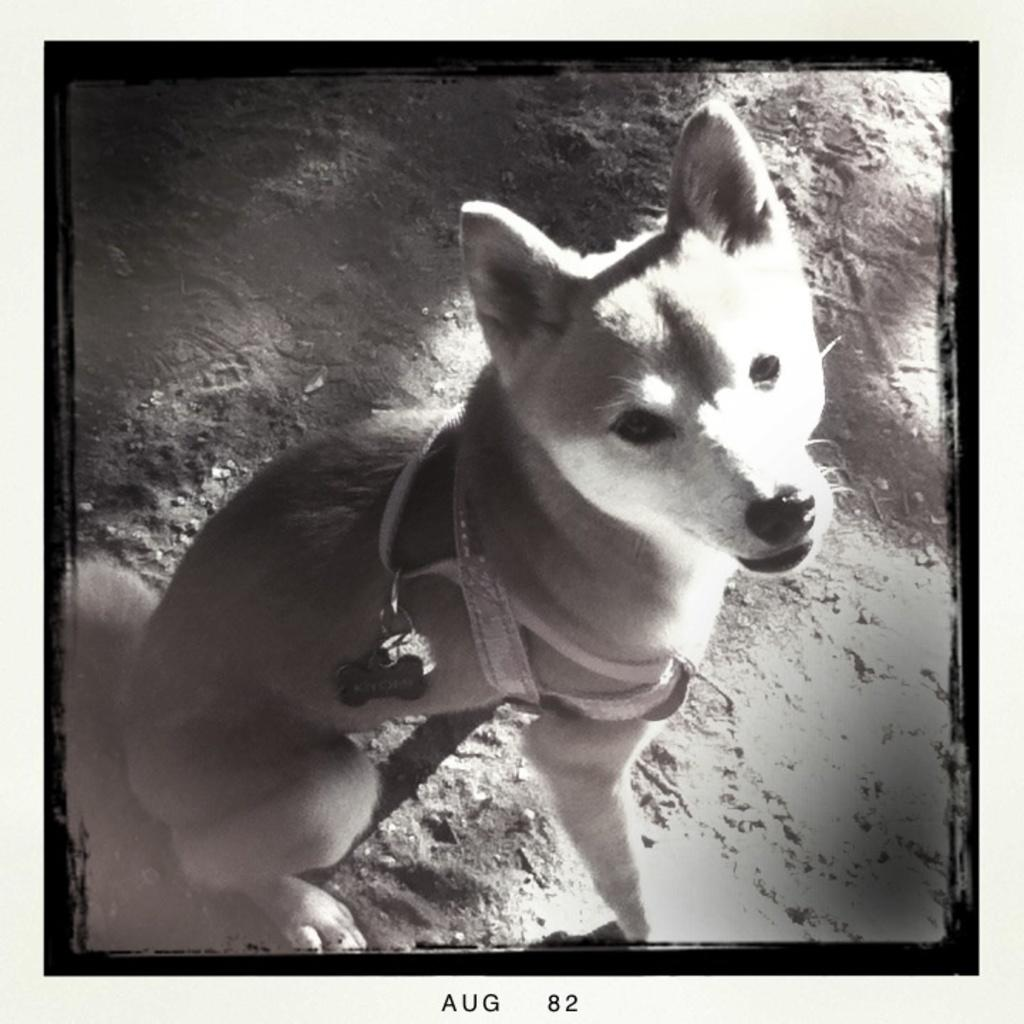What is the color scheme of the image? The image is black and white. What animal can be seen in the image? There is a dog in the image. Where is the dog located in the image? The dog is on the ground. What type of hook can be seen in the image? There is no hook present in the image. 